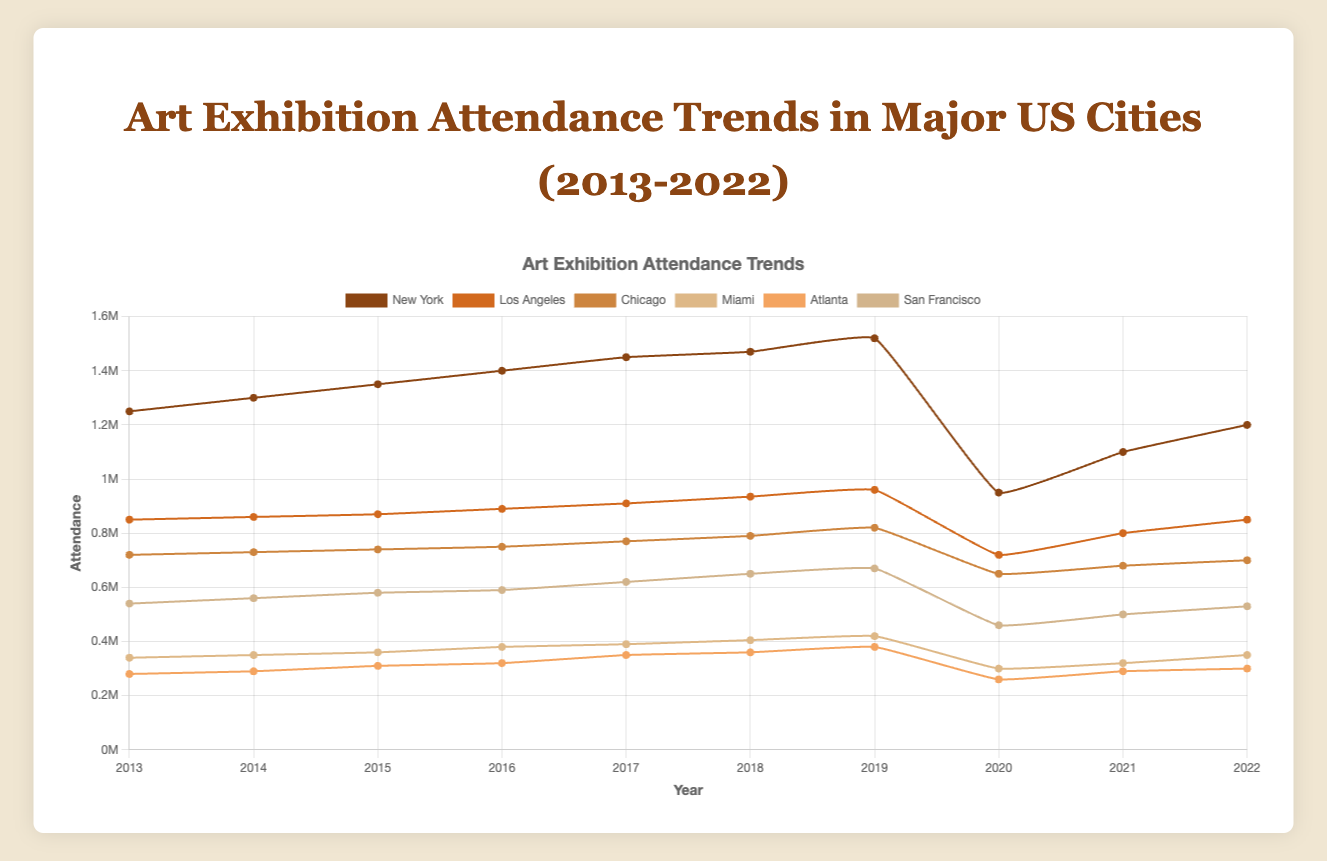What was the attendance in New York in 2019? To find the attendance in New York in 2019, locate New York's data points and check the value under the year 2019. The attendance in New York for 2019 is 1,520,000.
Answer: 1,520,000 Which city experienced the most significant decrease in attendance in 2020? To determine the city with the most significant decrease in 2020, compare the values for each city between 2019 and 2020. New York saw the most significant drop from 1,520,000 in 2019 to 950,000 in 2020, a decrease of 570,000.
Answer: New York How did Atlanta's attendance in 2022 compare to 2021? Compare the attendance values for Atlanta in 2021 and 2022 by identifying the corresponding data points. Atlanta's attendance in 2021 is 290,000 and in 2022 is 300,000, showing an increase of 10,000.
Answer: Increased by 10,000 What is the approximate average attendance in Los Angeles over the decade? Calculate the average attendance by summing Los Angeles's attendance values from 2013 to 2022 and dividing by 10. (850,000 + 860,000 + 870,000 + 890,000 + 910,000 + 935,000 + 960,000 + 720,000 + 800,000 + 850,000) / 10 = 864,500.
Answer: 864,500 Which city had the highest attendance in 2018? Review the attendance values for all cities in 2018. The highest attendance in 2018 is in New York, with 1,470,000 visitors.
Answer: New York Was there any year when all six cities had a decline in attendance? Compare the attendance values for each city year-by-year to see if all cities experienced a decline in any year. In 2020, all cities had a decline in attendance compared to 2019.
Answer: 2020 What's the difference in attendance between San Francisco and Miami in 2015? Find the 2015 attendance values for both cities and calculate the difference. San Francisco's attendance in 2015 is 580,000, and Miami's is 360,000. The difference is 580,000 - 360,000 = 220,000.
Answer: 220,000 Rank the cities based on their attendance in 2021 from highest to lowest. Extract the 2021 attendance data for each city and sort them in descending order. New York: 1,100,000, Los Angeles: 800,000, Chicago: 680,000, San Francisco: 500,000, Miami: 320,000, Atlanta: 290,000.
Answer: New York, Los Angeles, Chicago, San Francisco, Miami, Atlanta What was the general trend in attendance for Chicago from 2013 to 2019? Analyze Chicago's attendance data over the years. Chicago shows a consistent upward trend from 2013 (720,000) to 2019 (820,000).
Answer: Upward trend 